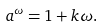Convert formula to latex. <formula><loc_0><loc_0><loc_500><loc_500>a ^ { \omega } = 1 + k \omega .</formula> 